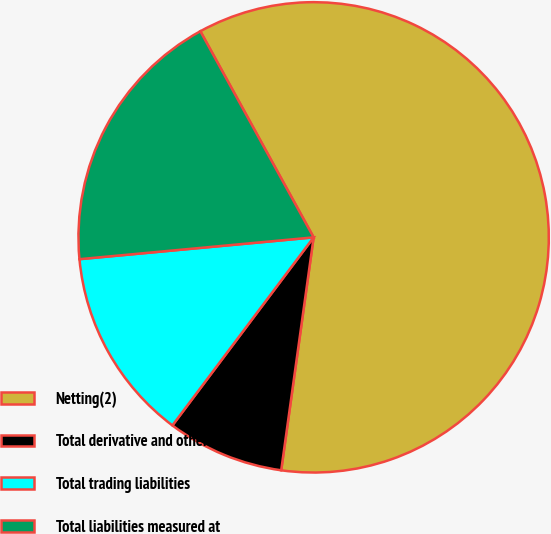<chart> <loc_0><loc_0><loc_500><loc_500><pie_chart><fcel>Netting(2)<fcel>Total derivative and other<fcel>Total trading liabilities<fcel>Total liabilities measured at<nl><fcel>60.2%<fcel>8.05%<fcel>13.27%<fcel>18.48%<nl></chart> 